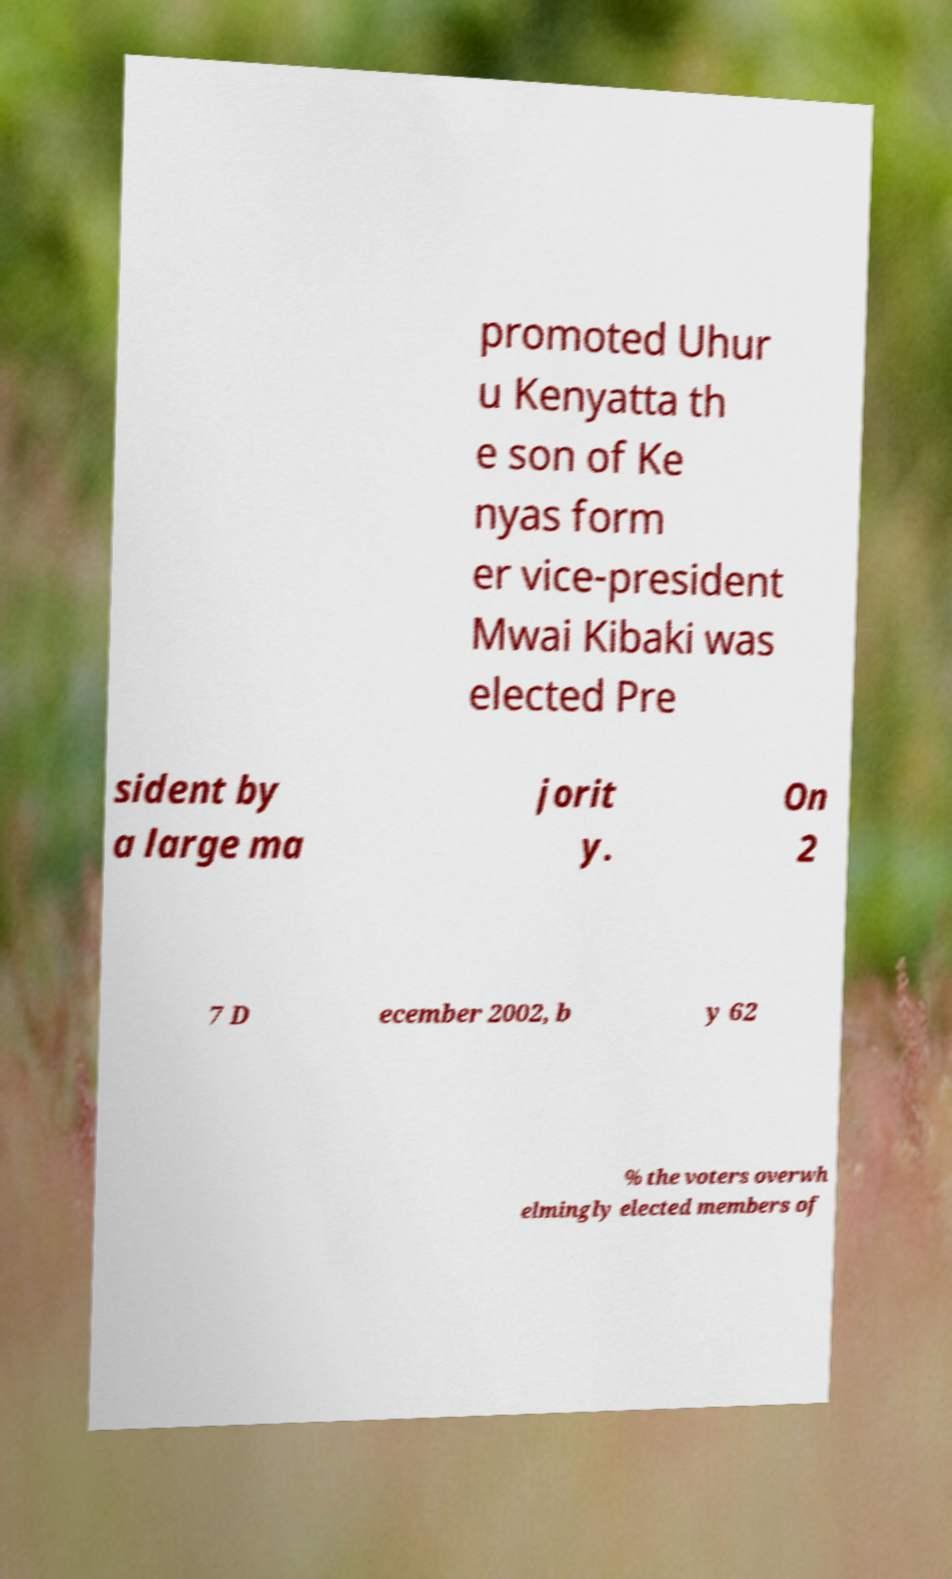What messages or text are displayed in this image? I need them in a readable, typed format. promoted Uhur u Kenyatta th e son of Ke nyas form er vice-president Mwai Kibaki was elected Pre sident by a large ma jorit y. On 2 7 D ecember 2002, b y 62 % the voters overwh elmingly elected members of 